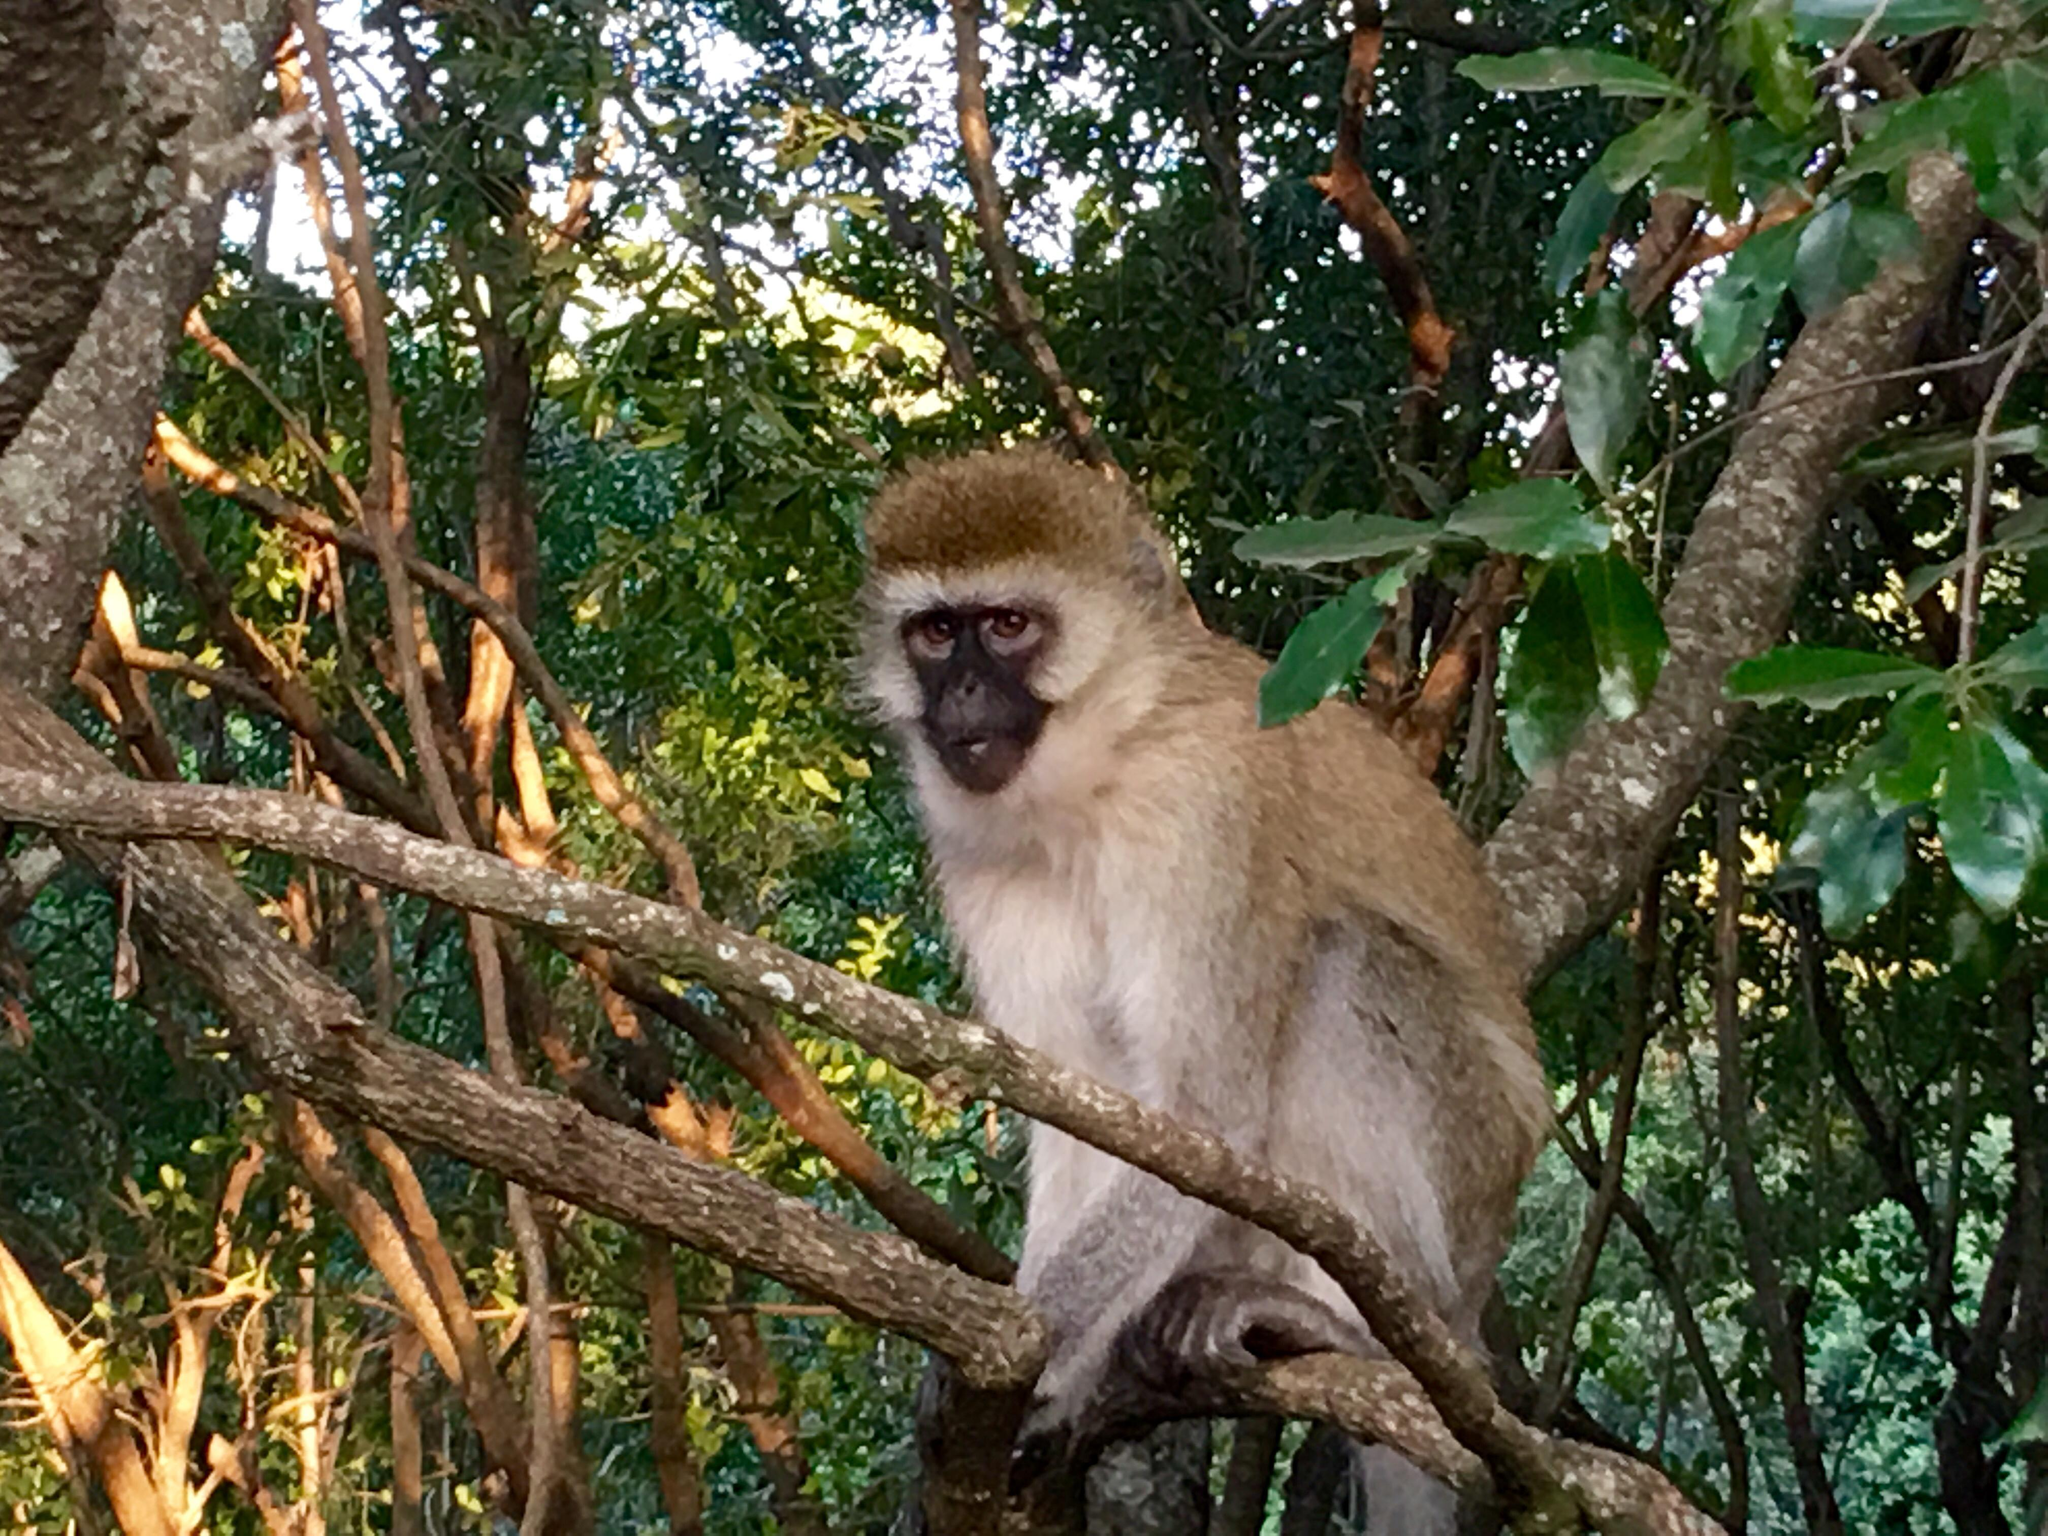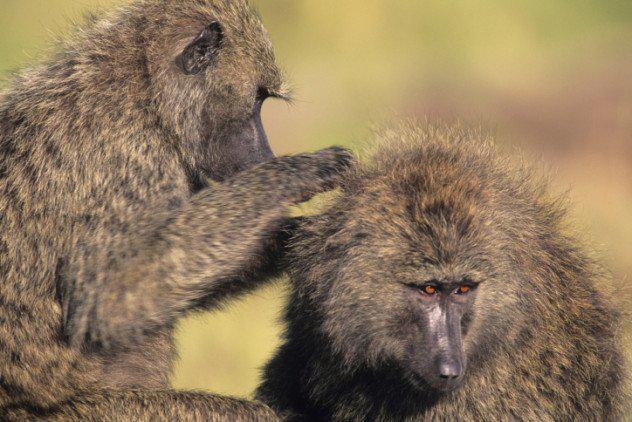The first image is the image on the left, the second image is the image on the right. For the images shown, is this caption "There are no more than three monkeys total per pair of images." true? Answer yes or no. Yes. The first image is the image on the left, the second image is the image on the right. Examine the images to the left and right. Is the description "A pink-faced baby baboo is held to the chest of its rightward-turned mother in one image." accurate? Answer yes or no. No. The first image is the image on the left, the second image is the image on the right. Considering the images on both sides, is "There are at most three monkeys" valid? Answer yes or no. Yes. The first image is the image on the left, the second image is the image on the right. For the images displayed, is the sentence "The right image contains at least two baboons." factually correct? Answer yes or no. Yes. 